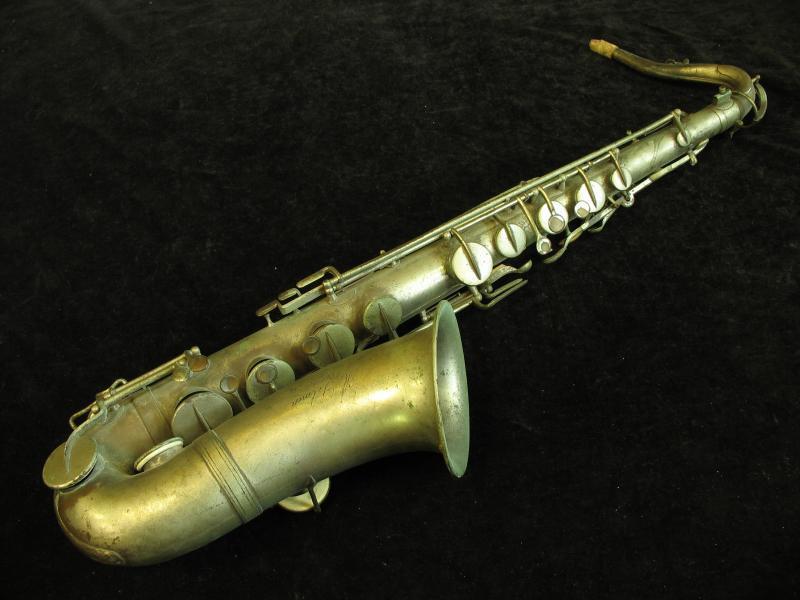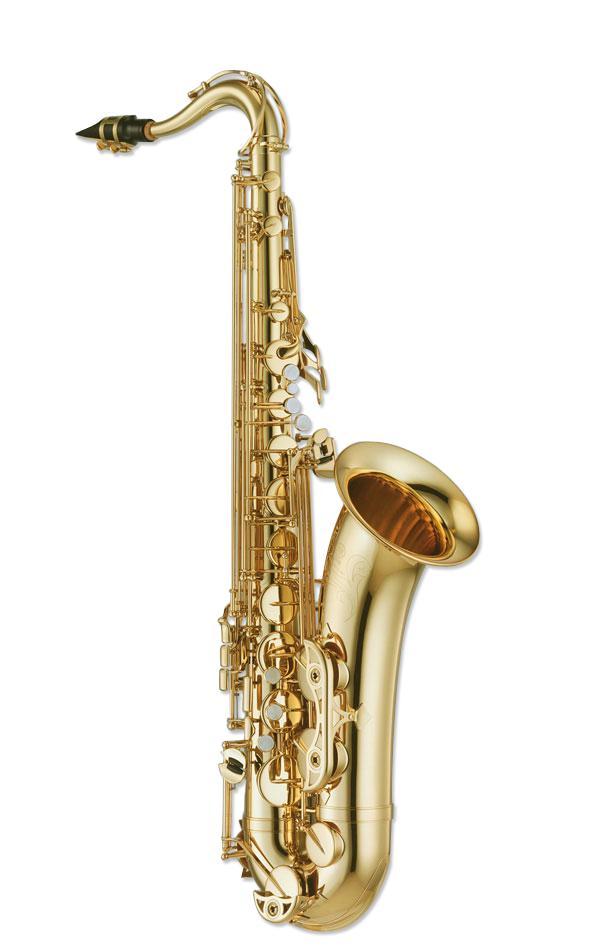The first image is the image on the left, the second image is the image on the right. Examine the images to the left and right. Is the description "An image shows a brass colored instrument with an imperfect finish on a black background." accurate? Answer yes or no. Yes. The first image is the image on the left, the second image is the image on the right. Given the left and right images, does the statement "One image shows a saxophone on a plain black background." hold true? Answer yes or no. Yes. 